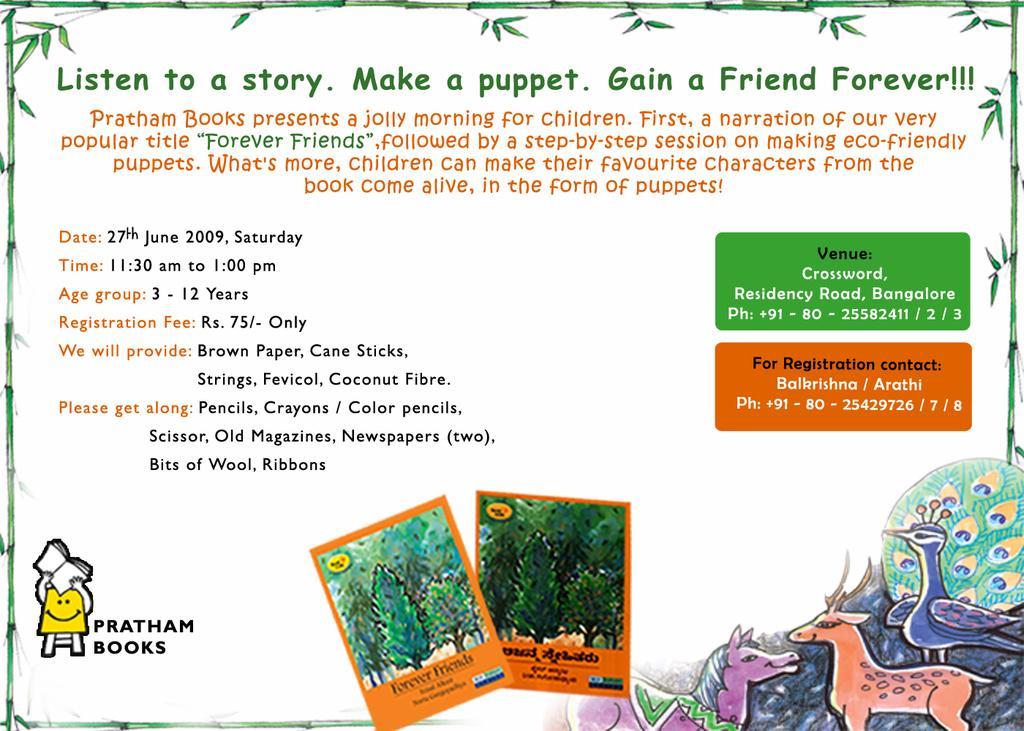How would you summarize this image in a sentence or two? In this image we can see a picture, in which we can see some text, some trees. In the right side of the image we can see some cartoons. 